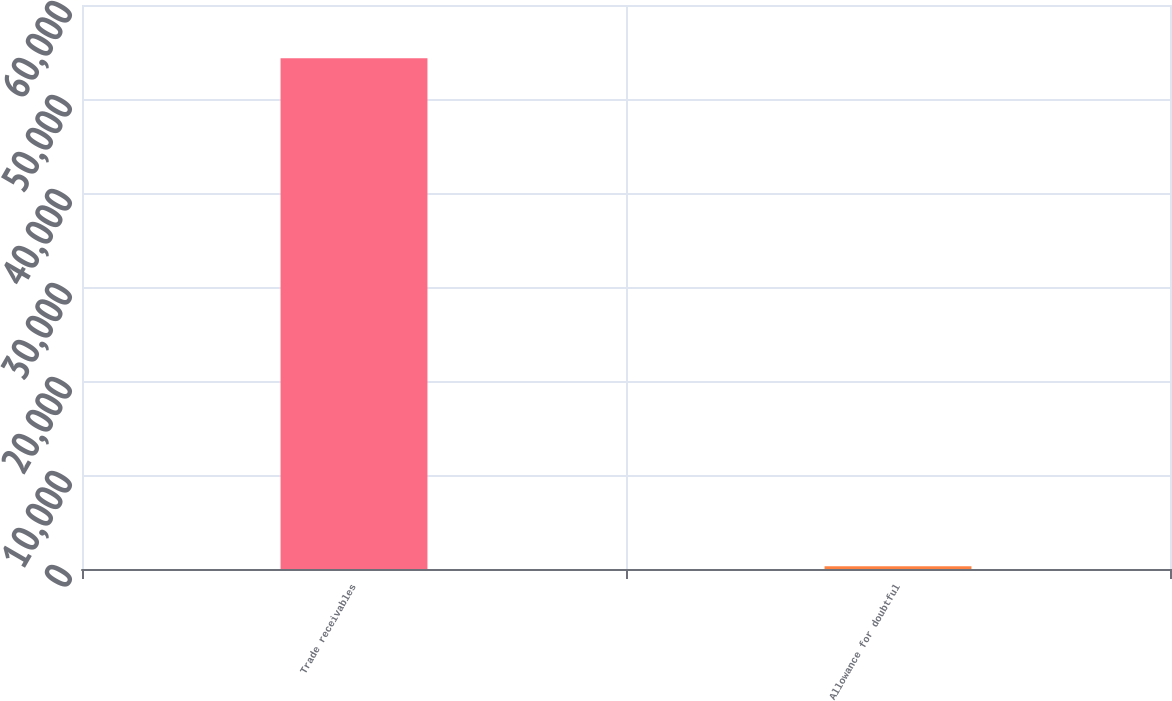<chart> <loc_0><loc_0><loc_500><loc_500><bar_chart><fcel>Trade receivables<fcel>Allowance for doubtful<nl><fcel>54337<fcel>282<nl></chart> 